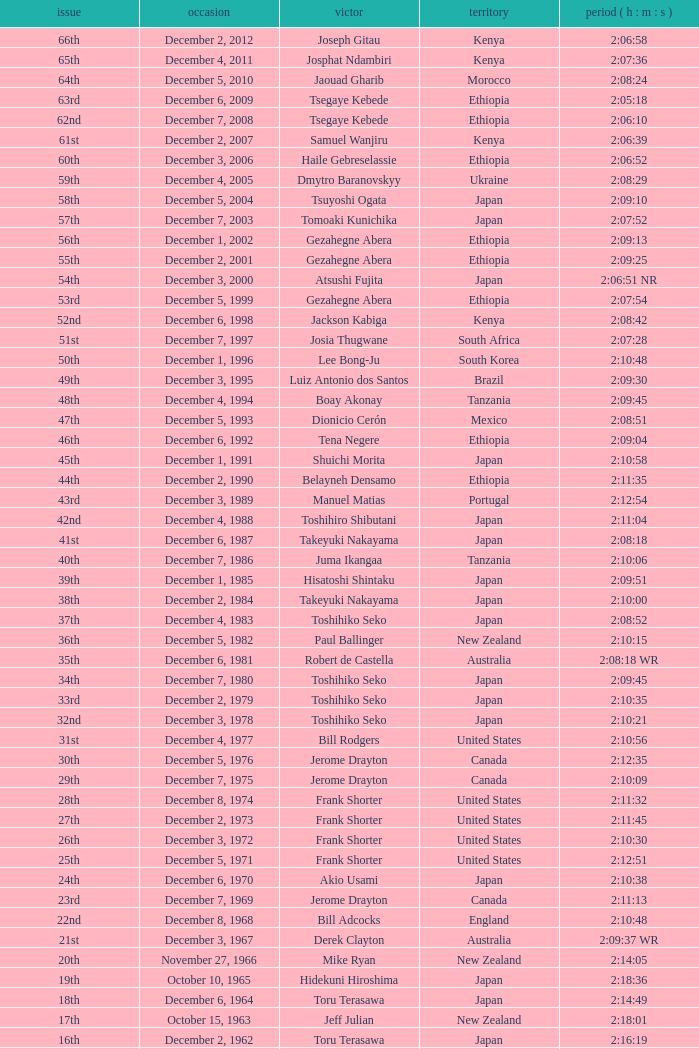What was the nationality of the winner of the 42nd Edition? Japan. 